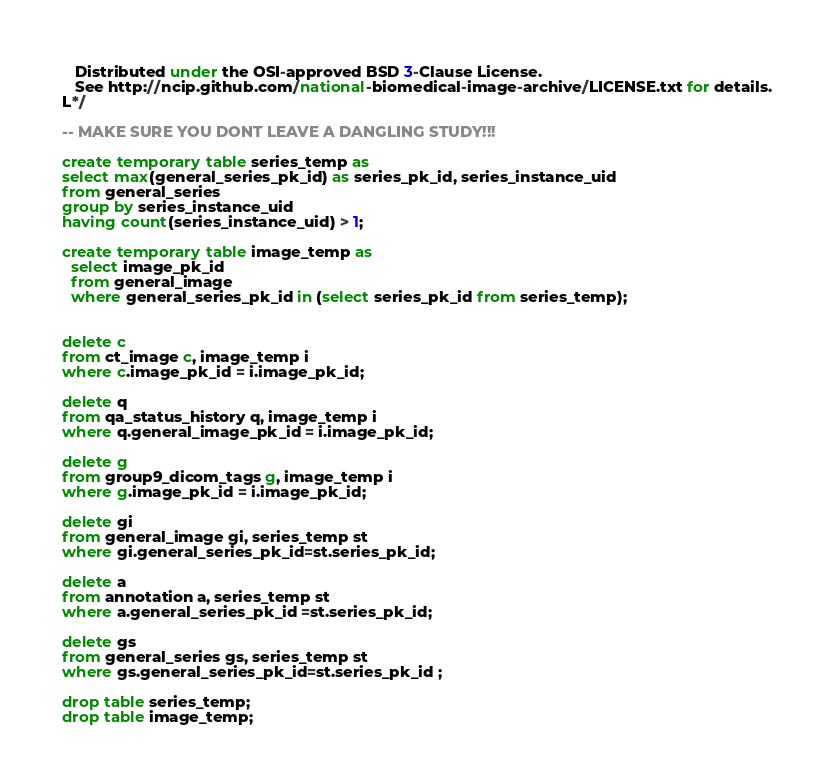Convert code to text. <code><loc_0><loc_0><loc_500><loc_500><_SQL_>

   Distributed under the OSI-approved BSD 3-Clause License.
   See http://ncip.github.com/national-biomedical-image-archive/LICENSE.txt for details.
L*/

-- MAKE SURE YOU DONT LEAVE A DANGLING STUDY!!!

create temporary table series_temp as 
select max(general_series_pk_id) as series_pk_id, series_instance_uid
from general_series
group by series_instance_uid
having count(series_instance_uid) > 1;

create temporary table image_temp as 
  select image_pk_id 
  from general_image 
  where general_series_pk_id in (select series_pk_id from series_temp);


delete c
from ct_image c, image_temp i
where c.image_pk_id = i.image_pk_id;

delete q
from qa_status_history q, image_temp i
where q.general_image_pk_id = i.image_pk_id;

delete g
from group9_dicom_tags g, image_temp i
where g.image_pk_id = i.image_pk_id;

delete gi
from general_image gi, series_temp st
where gi.general_series_pk_id=st.series_pk_id;

delete a
from annotation a, series_temp st  
where a.general_series_pk_id =st.series_pk_id;

delete gs
from general_series gs, series_temp st
where gs.general_series_pk_id=st.series_pk_id ;

drop table series_temp;
drop table image_temp;
</code> 